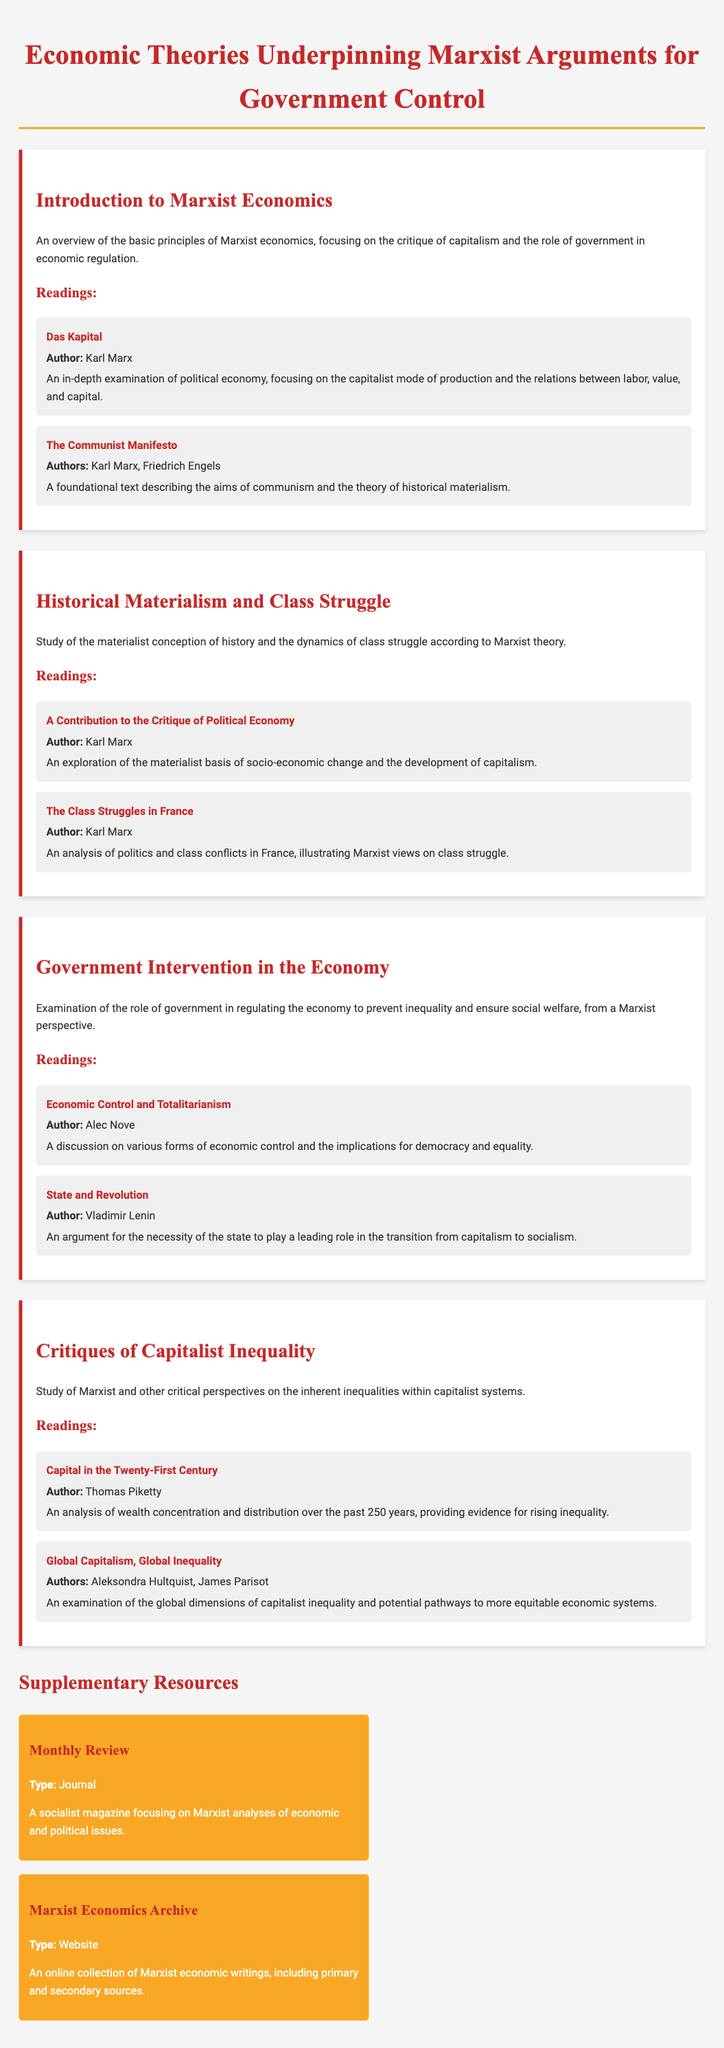What is the title of the syllabus? The title of the syllabus is explicitly stated at the top of the document.
Answer: Economic Theories Underpinning Marxist Arguments for Government Control Who is the author of "Das Kapital"? The author is mentioned alongside the title in the reading section of the syllabus.
Answer: Karl Marx What is the main focus of the module titled "Government Intervention in the Economy"? The focus is described in the introductory sentence for that module.
Answer: Regulating the economy to prevent inequality Which text analyzes politics and class conflicts in France? The text is specified in the readings of the "Historical Materialism and Class Struggle" module.
Answer: The Class Struggles in France How many resource entries are provided in the supplementary resources section? The number of entries can be counted in the document, specifically in the supplementary resources section.
Answer: 2 What type of document is "Monthly Review"? The type is indicated in the description of the supplementary resource.
Answer: Journal In which year was "Capital in the Twenty-First Century" published? The publication year is often important but not explicitly mentioned in the syllabus; however, knowing it aids understanding context.
Answer: 2013 (not directly found in document but common reference) Who are the authors of "Global Capitalism, Global Inequality"? The authorship is stated with the title in the readings section.
Answer: Aleksondra Hultquist, James Parisot 